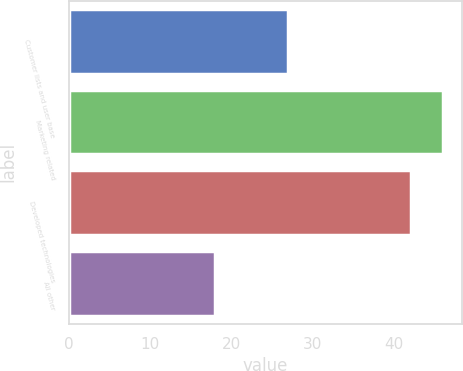Convert chart. <chart><loc_0><loc_0><loc_500><loc_500><bar_chart><fcel>Customer lists and user base<fcel>Marketing related<fcel>Developed technologies<fcel>All other<nl><fcel>27<fcel>46<fcel>42<fcel>18<nl></chart> 